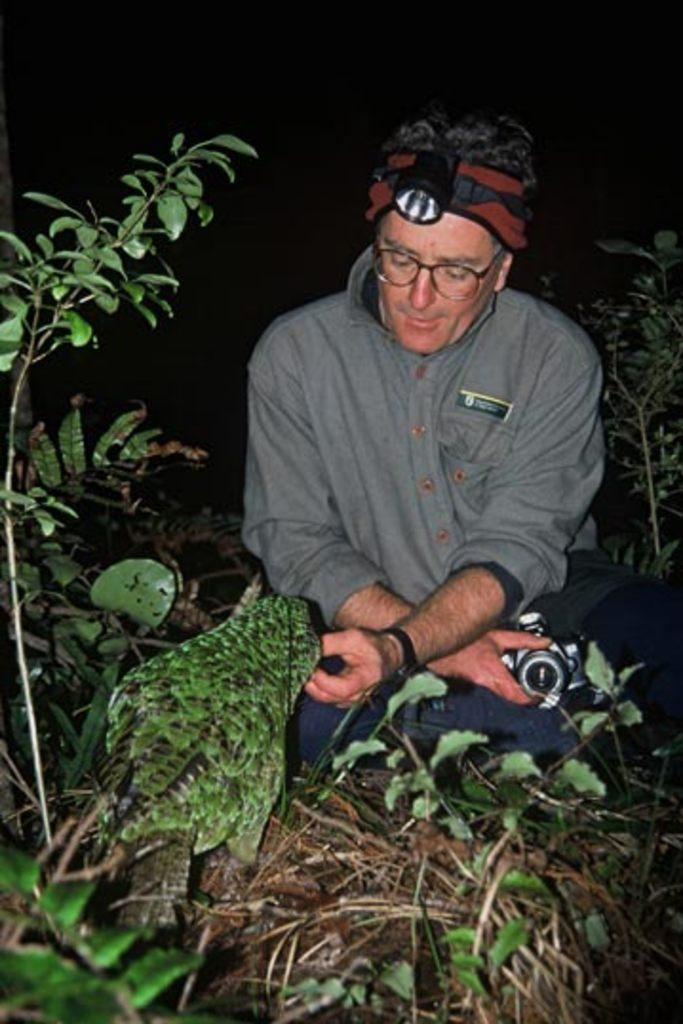What can be seen in the image? There is a person in the image. Can you describe the person's appearance? The person is wearing glasses and a headlamp. What is the person holding in the image? The person is holding an object. What can be seen in the background of the image? There are plants and a bird visible in the background. What type of peace is the person promoting in the image? There is no indication in the image that the person is promoting peace or any specific cause. How many bears can be seen in the image? There are no bears present in the image. 